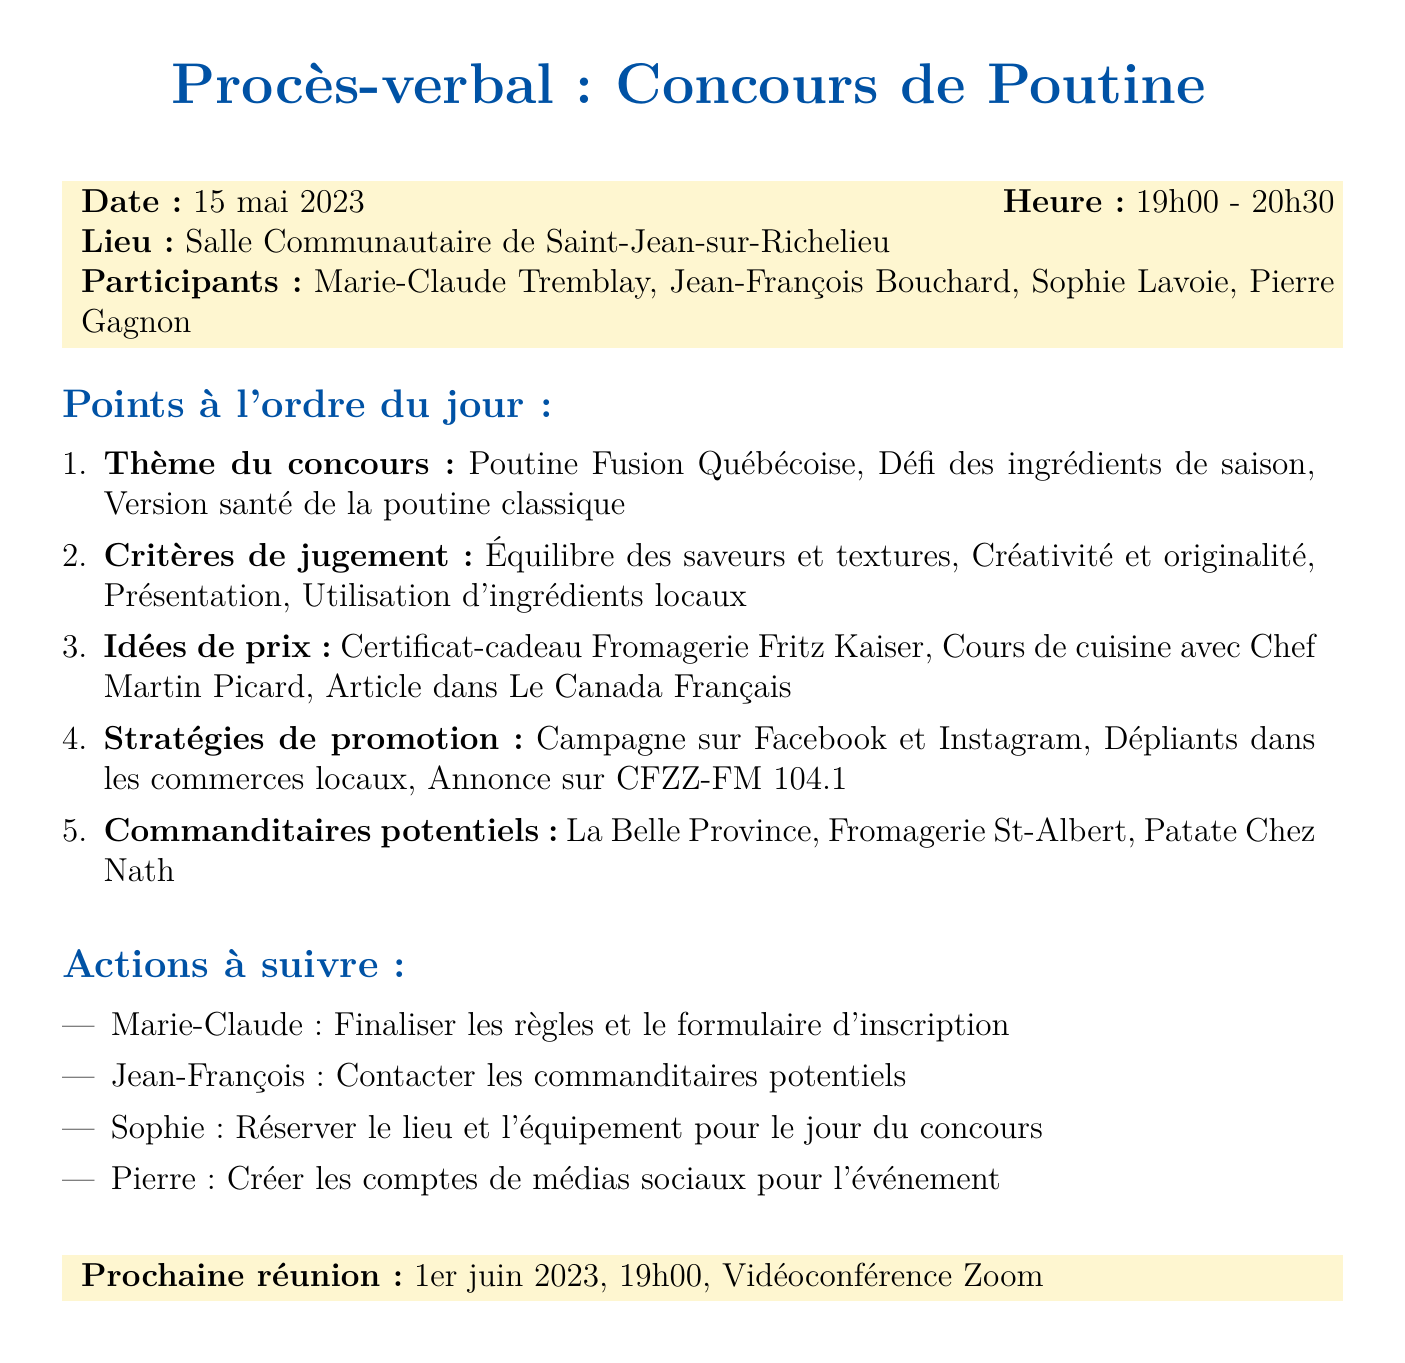What is the date of the meeting? The date of the meeting is mentioned at the beginning of the document.
Answer: 15 mai 2023 Who is the organizer of the contest? The organizer is listed among the attendees.
Answer: Marie-Claude Tremblay What are the three themes discussed for the contest? The themes are listed in the agenda items section under "Contest Theme."
Answer: Poutine Fusion Québécoise, Seasonal Ingredient Challenge, Healthier Twist on Classic Poutine What criteria will be used for judging? The judging criteria are specified in the agenda items section under "Judging Criteria."
Answer: Taste and texture balance, Creativity and originality, Presentation, Use of local ingredients What is one of the prize ideas for the contest? The prize ideas are mentioned under the "Prize Ideas" agenda item.
Answer: Gift certificate to Fromagerie Fritz Kaiser Who is responsible for creating social media accounts? The action items section details who is responsible for various tasks.
Answer: Pierre When is the next meeting scheduled? The date and time for the next meeting are stated in the last section of the document.
Answer: 1er juin 2023, 19h00 What type of promotion strategies were discussed? The promotion strategies are listed in the agenda items section under "Promotion Strategies."
Answer: Social media campaign on Facebook and Instagram Which local food truck is a potential sponsor? The potential sponsors are enumerated in the agenda items section.
Answer: Patate Chez Nath 